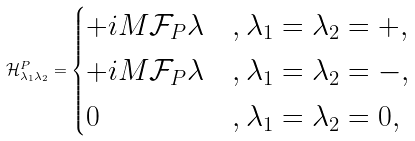<formula> <loc_0><loc_0><loc_500><loc_500>\mathcal { H } _ { \lambda _ { 1 } \lambda _ { 2 } } ^ { P } = \begin{cases} + i M \mathcal { F } _ { P } \lambda & , \lambda _ { 1 } = \lambda _ { 2 } = + , \\ + i M \mathcal { F } _ { P } \lambda & , \lambda _ { 1 } = \lambda _ { 2 } = - , \\ 0 & , \lambda _ { 1 } = \lambda _ { 2 } = 0 , \end{cases}</formula> 